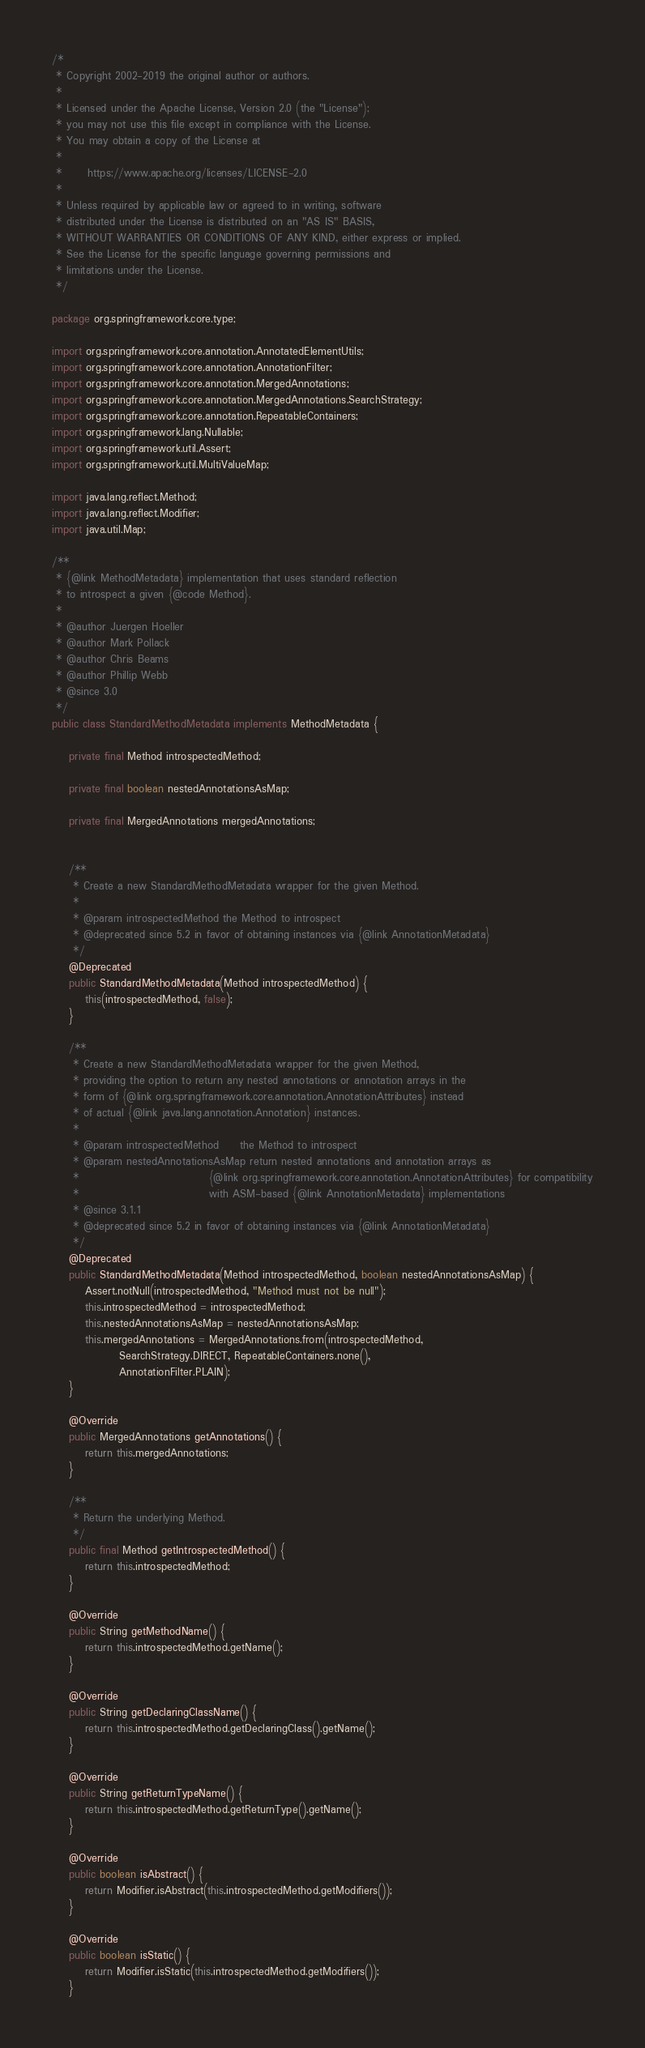Convert code to text. <code><loc_0><loc_0><loc_500><loc_500><_Java_>/*
 * Copyright 2002-2019 the original author or authors.
 *
 * Licensed under the Apache License, Version 2.0 (the "License");
 * you may not use this file except in compliance with the License.
 * You may obtain a copy of the License at
 *
 *      https://www.apache.org/licenses/LICENSE-2.0
 *
 * Unless required by applicable law or agreed to in writing, software
 * distributed under the License is distributed on an "AS IS" BASIS,
 * WITHOUT WARRANTIES OR CONDITIONS OF ANY KIND, either express or implied.
 * See the License for the specific language governing permissions and
 * limitations under the License.
 */

package org.springframework.core.type;

import org.springframework.core.annotation.AnnotatedElementUtils;
import org.springframework.core.annotation.AnnotationFilter;
import org.springframework.core.annotation.MergedAnnotations;
import org.springframework.core.annotation.MergedAnnotations.SearchStrategy;
import org.springframework.core.annotation.RepeatableContainers;
import org.springframework.lang.Nullable;
import org.springframework.util.Assert;
import org.springframework.util.MultiValueMap;

import java.lang.reflect.Method;
import java.lang.reflect.Modifier;
import java.util.Map;

/**
 * {@link MethodMetadata} implementation that uses standard reflection
 * to introspect a given {@code Method}.
 *
 * @author Juergen Hoeller
 * @author Mark Pollack
 * @author Chris Beams
 * @author Phillip Webb
 * @since 3.0
 */
public class StandardMethodMetadata implements MethodMetadata {

    private final Method introspectedMethod;

    private final boolean nestedAnnotationsAsMap;

    private final MergedAnnotations mergedAnnotations;


    /**
     * Create a new StandardMethodMetadata wrapper for the given Method.
     *
     * @param introspectedMethod the Method to introspect
     * @deprecated since 5.2 in favor of obtaining instances via {@link AnnotationMetadata}
     */
    @Deprecated
    public StandardMethodMetadata(Method introspectedMethod) {
        this(introspectedMethod, false);
    }

    /**
     * Create a new StandardMethodMetadata wrapper for the given Method,
     * providing the option to return any nested annotations or annotation arrays in the
     * form of {@link org.springframework.core.annotation.AnnotationAttributes} instead
     * of actual {@link java.lang.annotation.Annotation} instances.
     *
     * @param introspectedMethod     the Method to introspect
     * @param nestedAnnotationsAsMap return nested annotations and annotation arrays as
     *                               {@link org.springframework.core.annotation.AnnotationAttributes} for compatibility
     *                               with ASM-based {@link AnnotationMetadata} implementations
     * @since 3.1.1
     * @deprecated since 5.2 in favor of obtaining instances via {@link AnnotationMetadata}
     */
    @Deprecated
    public StandardMethodMetadata(Method introspectedMethod, boolean nestedAnnotationsAsMap) {
        Assert.notNull(introspectedMethod, "Method must not be null");
        this.introspectedMethod = introspectedMethod;
        this.nestedAnnotationsAsMap = nestedAnnotationsAsMap;
        this.mergedAnnotations = MergedAnnotations.from(introspectedMethod,
                SearchStrategy.DIRECT, RepeatableContainers.none(),
                AnnotationFilter.PLAIN);
    }

    @Override
    public MergedAnnotations getAnnotations() {
        return this.mergedAnnotations;
    }

    /**
     * Return the underlying Method.
     */
    public final Method getIntrospectedMethod() {
        return this.introspectedMethod;
    }

    @Override
    public String getMethodName() {
        return this.introspectedMethod.getName();
    }

    @Override
    public String getDeclaringClassName() {
        return this.introspectedMethod.getDeclaringClass().getName();
    }

    @Override
    public String getReturnTypeName() {
        return this.introspectedMethod.getReturnType().getName();
    }

    @Override
    public boolean isAbstract() {
        return Modifier.isAbstract(this.introspectedMethod.getModifiers());
    }

    @Override
    public boolean isStatic() {
        return Modifier.isStatic(this.introspectedMethod.getModifiers());
    }
</code> 